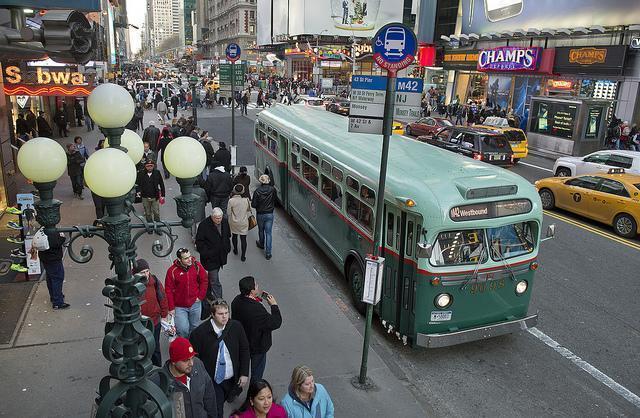Why are only the letters SBwa visible on that sign?
Answer the question by selecting the correct answer among the 4 following choices.
Options: Broken bulbs, correct name, spray paint, fallen letters. Broken bulbs. 